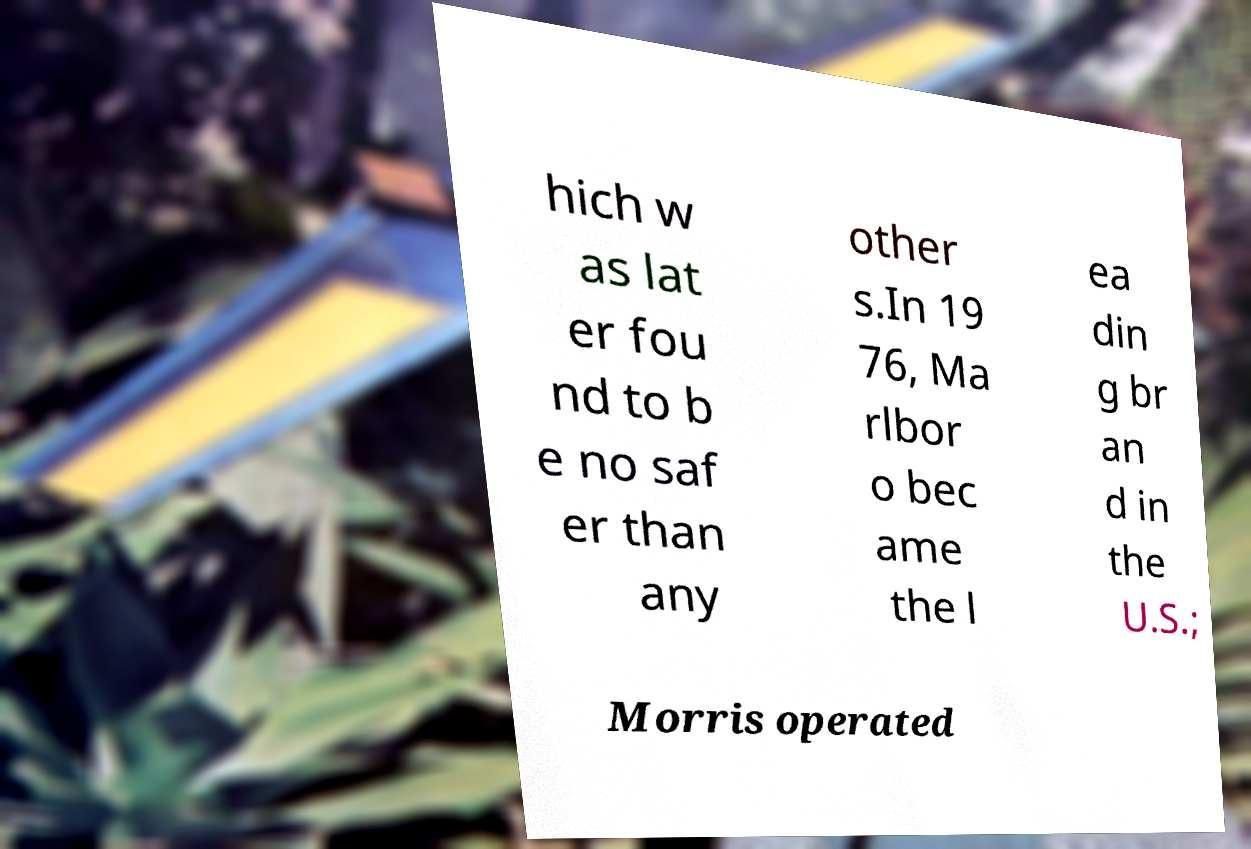Can you accurately transcribe the text from the provided image for me? hich w as lat er fou nd to b e no saf er than any other s.In 19 76, Ma rlbor o bec ame the l ea din g br an d in the U.S.; Morris operated 